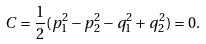Convert formula to latex. <formula><loc_0><loc_0><loc_500><loc_500>C = \frac { 1 } { 2 } ( p _ { 1 } ^ { 2 } - p _ { 2 } ^ { 2 } - q _ { 1 } ^ { 2 } + q _ { 2 } ^ { 2 } ) = 0 .</formula> 